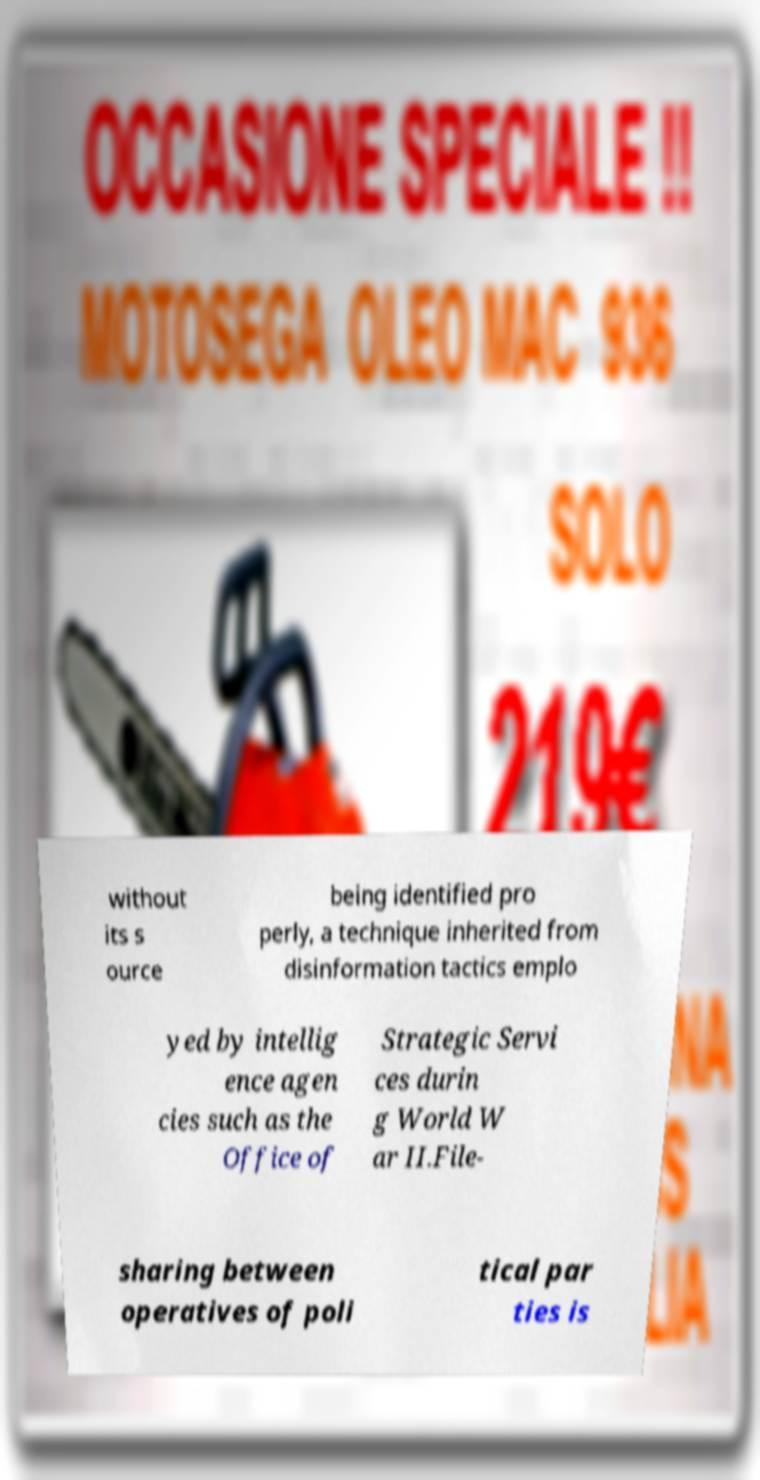Please read and relay the text visible in this image. What does it say? without its s ource being identified pro perly, a technique inherited from disinformation tactics emplo yed by intellig ence agen cies such as the Office of Strategic Servi ces durin g World W ar II.File- sharing between operatives of poli tical par ties is 